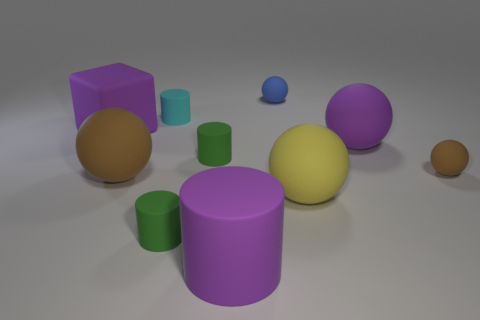Subtract all purple matte balls. How many balls are left? 4 Subtract 2 balls. How many balls are left? 3 Subtract all cyan cylinders. How many cylinders are left? 3 Subtract all red cylinders. Subtract all yellow balls. How many cylinders are left? 4 Subtract all cubes. How many objects are left? 9 Add 7 tiny matte spheres. How many tiny matte spheres exist? 9 Subtract 0 brown cylinders. How many objects are left? 10 Subtract all large brown objects. Subtract all blue matte objects. How many objects are left? 8 Add 1 yellow things. How many yellow things are left? 2 